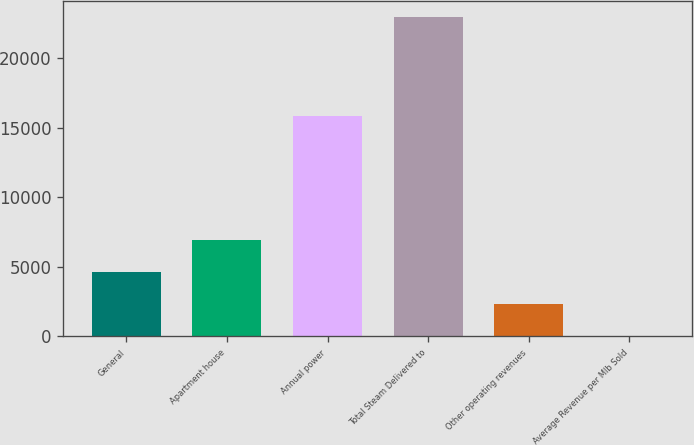Convert chart to OTSL. <chart><loc_0><loc_0><loc_500><loc_500><bar_chart><fcel>General<fcel>Apartment house<fcel>Annual power<fcel>Total Steam Delivered to<fcel>Other operating revenues<fcel>Average Revenue per Mlb Sold<nl><fcel>4626.8<fcel>6925.45<fcel>15848<fcel>23016<fcel>2328.15<fcel>29.5<nl></chart> 